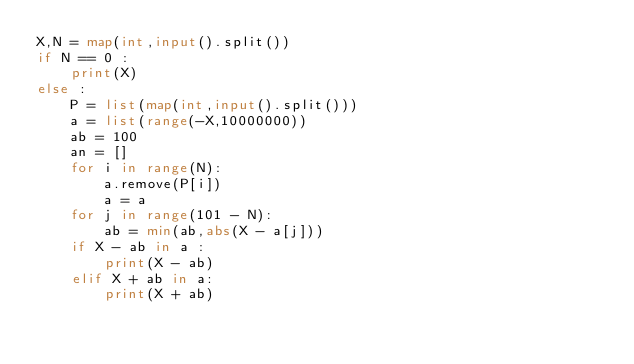<code> <loc_0><loc_0><loc_500><loc_500><_Python_>X,N = map(int,input().split())
if N == 0 :
    print(X)
else :
    P = list(map(int,input().split()))
    a = list(range(-X,10000000))
    ab = 100
    an = []
    for i in range(N):
        a.remove(P[i])
        a = a
    for j in range(101 - N):
        ab = min(ab,abs(X - a[j]))
    if X - ab in a :
        print(X - ab)
    elif X + ab in a:
        print(X + ab)
        
 

    </code> 